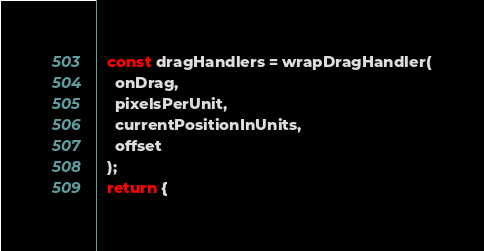Convert code to text. <code><loc_0><loc_0><loc_500><loc_500><_JavaScript_>  const dragHandlers = wrapDragHandler(
    onDrag,
    pixelsPerUnit,
    currentPositionInUnits,
    offset
  );
  return {</code> 